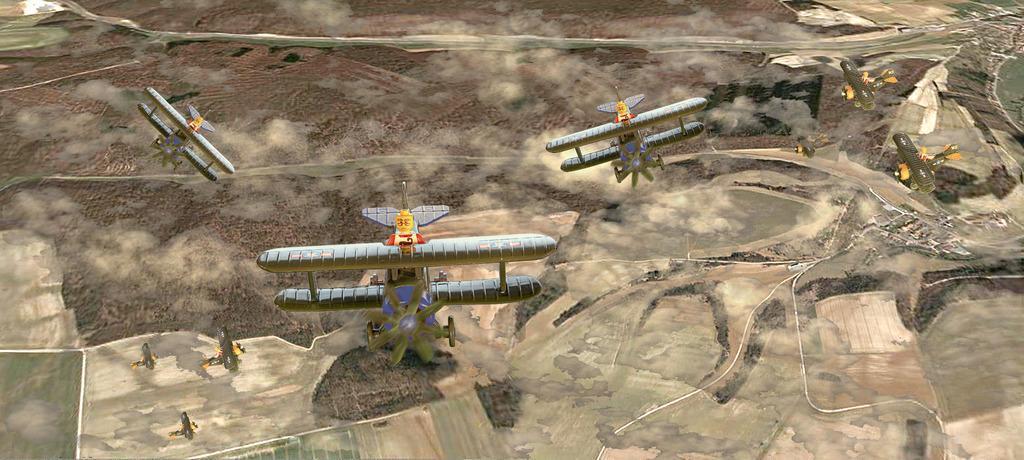How would you summarize this image in a sentence or two? This image is clicked from the top. There are so many airplanes. There is land at the bottom. There are trees in this image. 